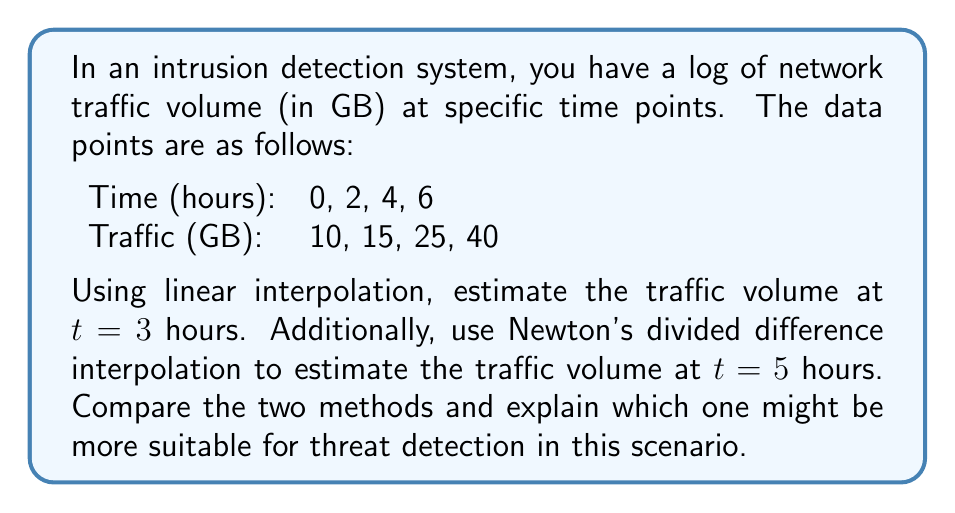Can you answer this question? Let's approach this problem step by step:

1. Linear Interpolation for t = 3 hours:

Linear interpolation uses the formula:
$$y = y_1 + \frac{(x - x_1)(y_2 - y_1)}{(x_2 - x_1)}$$

For t = 3, we'll use the data points (2, 15) and (4, 25):

$$y = 15 + \frac{(3 - 2)(25 - 15)}{(4 - 2)} = 15 + \frac{1 \times 10}{2} = 20$$

2. Newton's Divided Difference Interpolation for t = 5 hours:

First, we need to calculate the divided differences:

$f[x_i, x_{i+1}] = \frac{f(x_{i+1}) - f(x_i)}{x_{i+1} - x_i}$

$f[0,2] = \frac{15-10}{2-0} = 2.5$
$f[2,4] = \frac{25-15}{4-2} = 5$
$f[4,6] = \frac{40-25}{6-4} = 7.5$

$f[0,2,4] = \frac{f[2,4] - f[0,2]}{4-0} = \frac{5-2.5}{4} = 0.625$
$f[2,4,6] = \frac{f[4,6] - f[2,4]}{6-2} = \frac{7.5-5}{4} = 0.625$

$f[0,2,4,6] = \frac{f[2,4,6] - f[0,2,4]}{6-0} = \frac{0.625-0.625}{6} = 0$

Now, we can use Newton's interpolation formula:
$$f(x) = f(x_0) + f[x_0,x_1](x-x_0) + f[x_0,x_1,x_2](x-x_0)(x-x_1) + f[x_0,x_1,x_2,x_3](x-x_0)(x-x_1)(x-x_2)$$

For t = 5:
$$f(5) = 10 + 2.5(5-0) + 0.625(5-0)(5-2) + 0(5-0)(5-2)(5-4)$$
$$f(5) = 10 + 12.5 + 9.375 + 0 = 31.875$$

3. Comparison:

Linear interpolation assumes a constant rate of change between known points, which may not capture sudden spikes in traffic that could indicate a threat. 

Newton's divided difference interpolation considers the overall trend of the data, potentially providing a more accurate estimate for non-linear patterns in network traffic.

For threat detection, Newton's method might be more suitable as it can better capture sudden changes or anomalies in traffic patterns, which could be indicative of potential security threats.
Answer: Linear interpolation estimate at t = 3 hours: 20 GB
Newton's divided difference interpolation estimate at t = 5 hours: 31.875 GB

Newton's method is likely more suitable for threat detection in this scenario as it better captures non-linear patterns and potential anomalies in network traffic. 